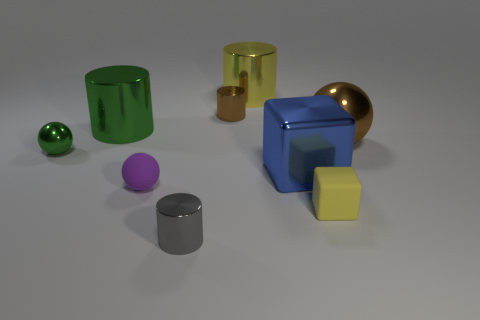Subtract all spheres. How many objects are left? 6 Subtract all small green metal spheres. Subtract all brown balls. How many objects are left? 7 Add 8 big yellow objects. How many big yellow objects are left? 9 Add 7 large yellow metal objects. How many large yellow metal objects exist? 8 Subtract 1 blue blocks. How many objects are left? 8 